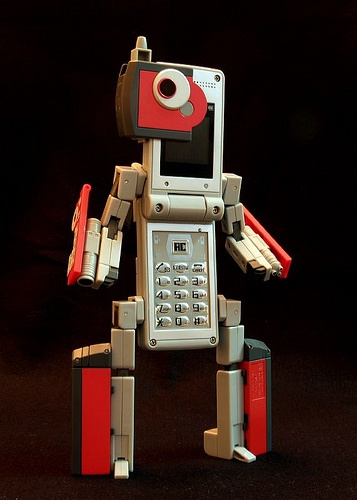Describe the objects in this image and their specific colors. I can see a cell phone in black, ivory, darkgray, and gray tones in this image. 